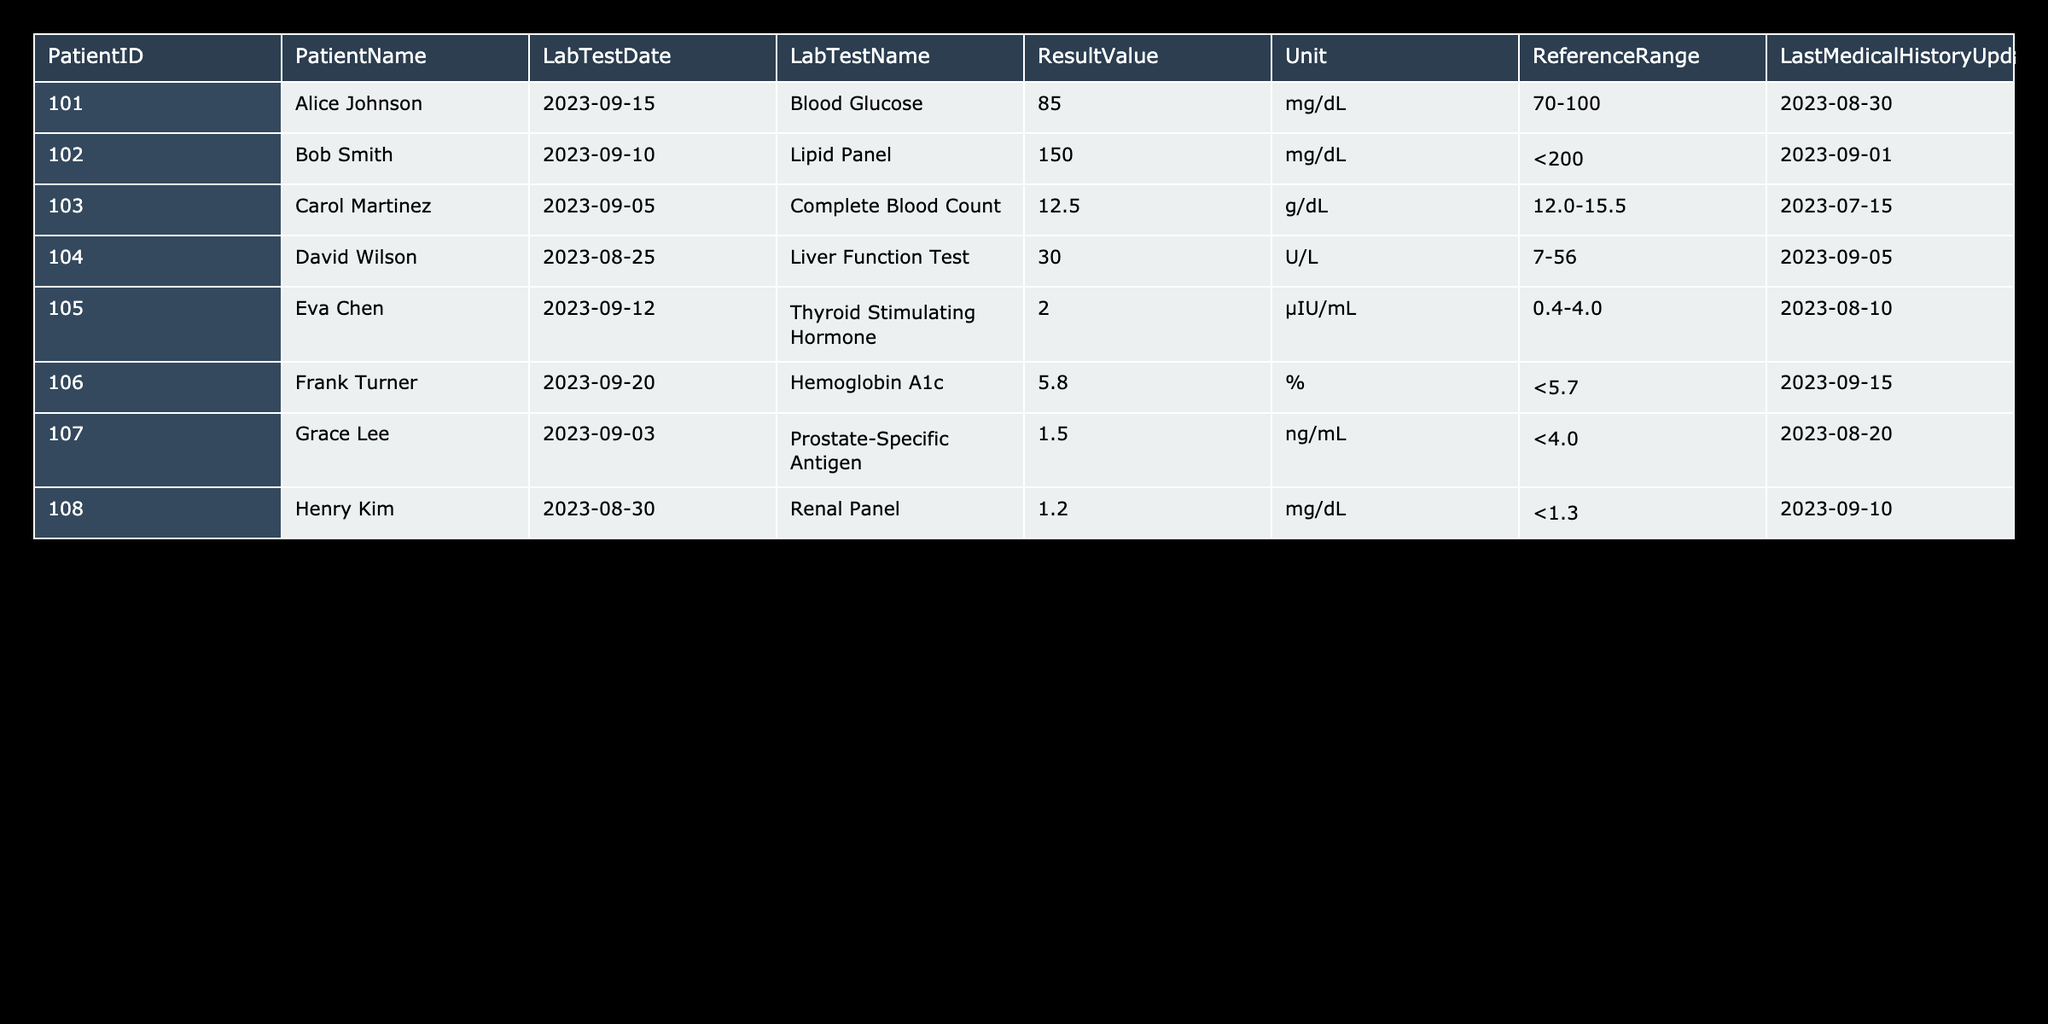What is the lab test date for David Wilson? David Wilson's entry in the table shows that his Lab Test Date is specifically listed as '2023-08-25'.
Answer: 2023-08-25 How many patients have a Last Medical History Update after September 1, 2023? By reviewing the Last Medical History Update column, only two patients—Frank Turner (2023-09-15) and Henry Kim (2023-09-10)—have updates after September 1, 2023. Thus, the count is two.
Answer: 2 Is Bob Smith's Lipid Panel result within the reference range? Bob Smith's Lipid Panel result is listed as 150 mg/dL, and the reference range is <200 mg/dL. Since 150 is less than 200, the result is indeed within the range specified.
Answer: Yes What is the average Hemoglobin A1c result for patients from the table? Only one patient—Frank Turner—has a Hemoglobin A1c result listed, which is 5.8%. Since there is only one entry, the average is 5.8% as there are no other results to average with.
Answer: 5.8% What is the difference in result values between Henry Kim's Renal Panel and Alice Johnson's Blood Glucose? Henry Kim's Renal Panel result is 1.2 mg/dL and Alice Johnson's Blood Glucose result is 85 mg/dL. The difference is: 85 - 1.2 = 83.8. Therefore, the difference in result values is 83.8.
Answer: 83.8 